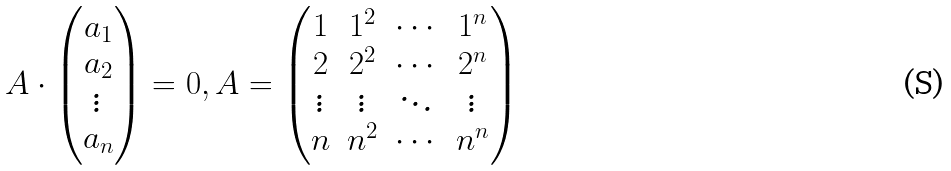<formula> <loc_0><loc_0><loc_500><loc_500>A \cdot \begin{pmatrix} a _ { 1 } \\ a _ { 2 } \\ \vdots \\ a _ { n } \end{pmatrix} = 0 , A = \begin{pmatrix} 1 & 1 ^ { 2 } & \cdots & 1 ^ { n } \\ 2 & 2 ^ { 2 } & \cdots & 2 ^ { n } \\ \vdots & \vdots & \ddots & \vdots \\ n & n ^ { 2 } & \cdots & n ^ { n } \end{pmatrix}</formula> 